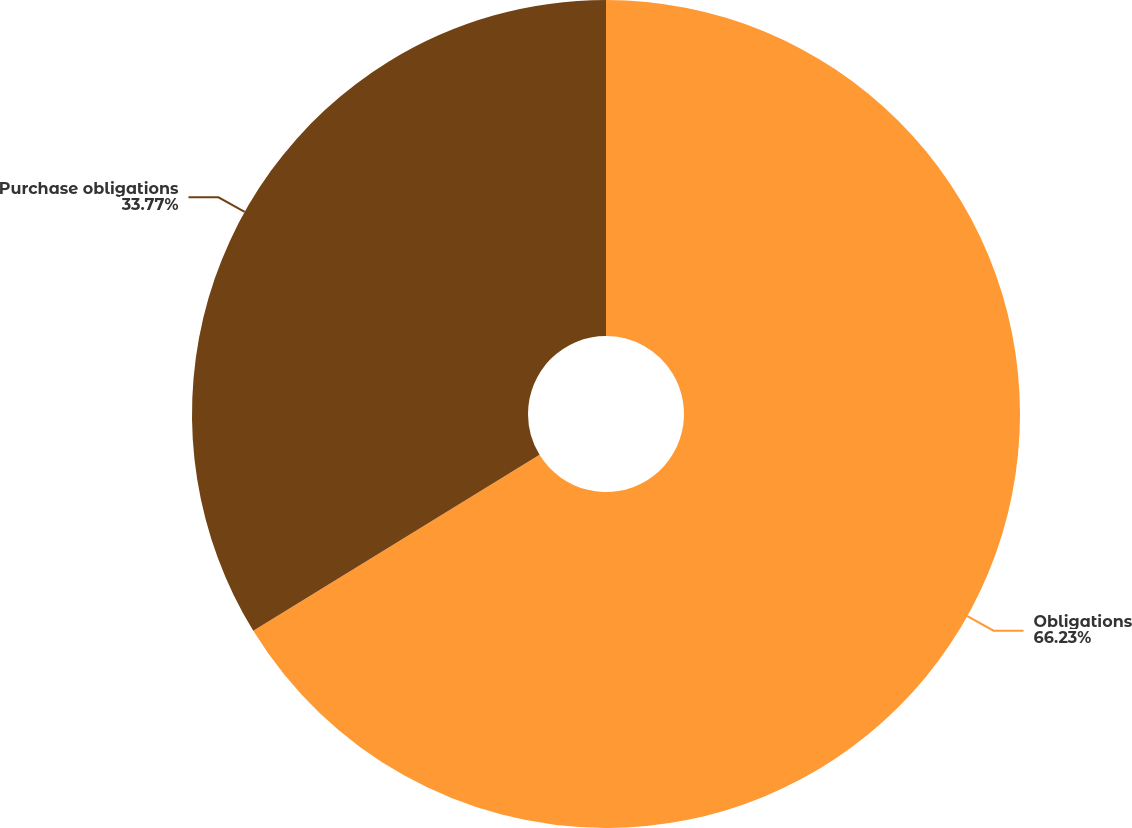Convert chart. <chart><loc_0><loc_0><loc_500><loc_500><pie_chart><fcel>Obligations<fcel>Purchase obligations<nl><fcel>66.23%<fcel>33.77%<nl></chart> 